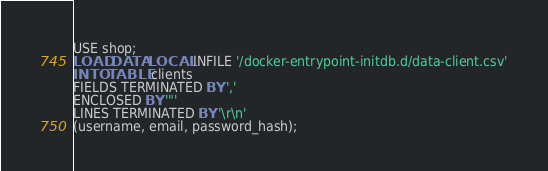<code> <loc_0><loc_0><loc_500><loc_500><_SQL_>USE shop;
LOAD DATA LOCAL INFILE '/docker-entrypoint-initdb.d/data-client.csv'
INTO TABLE clients
FIELDS TERMINATED BY ','
ENCLOSED BY '"'
LINES TERMINATED BY '\r\n'
(username, email, password_hash);</code> 